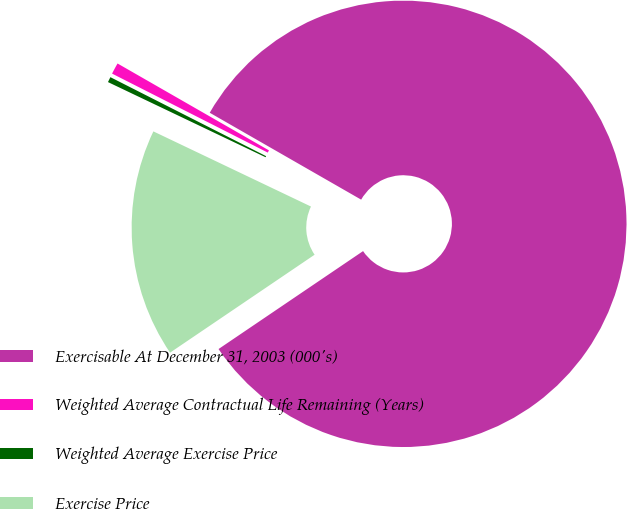<chart> <loc_0><loc_0><loc_500><loc_500><pie_chart><fcel>Exercisable At December 31, 2003 (000's)<fcel>Weighted Average Contractual Life Remaining (Years)<fcel>Weighted Average Exercise Price<fcel>Exercise Price<nl><fcel>82.23%<fcel>0.82%<fcel>0.39%<fcel>16.56%<nl></chart> 